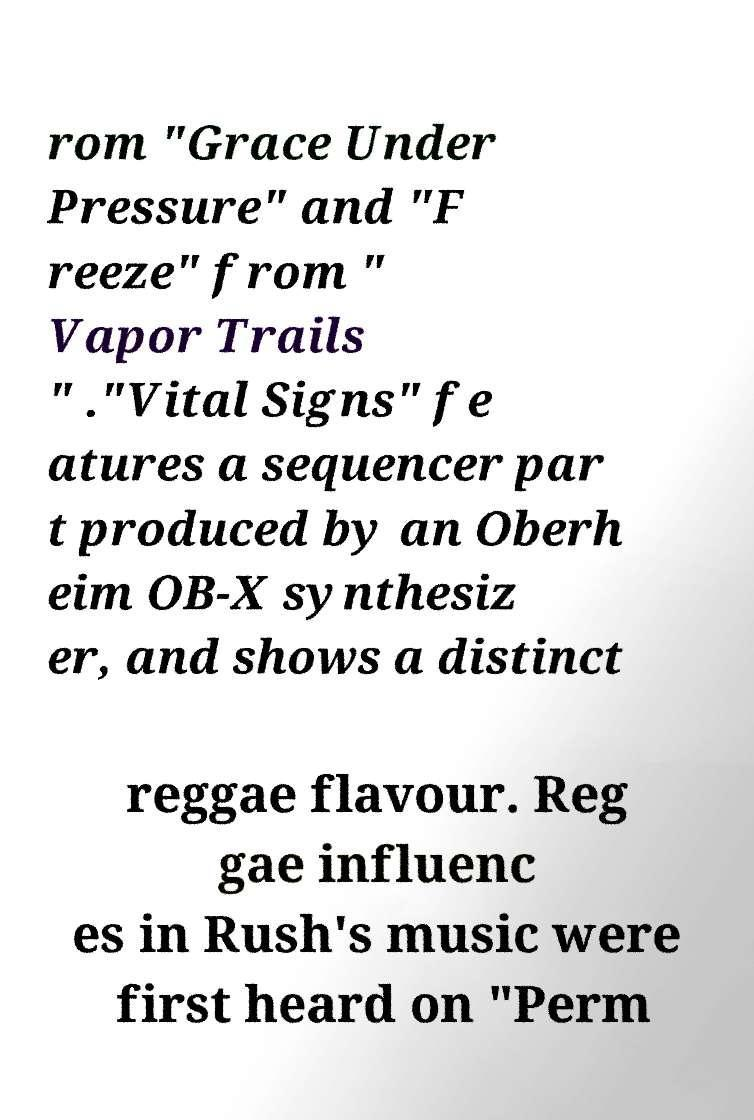For documentation purposes, I need the text within this image transcribed. Could you provide that? rom "Grace Under Pressure" and "F reeze" from " Vapor Trails " ."Vital Signs" fe atures a sequencer par t produced by an Oberh eim OB-X synthesiz er, and shows a distinct reggae flavour. Reg gae influenc es in Rush's music were first heard on "Perm 